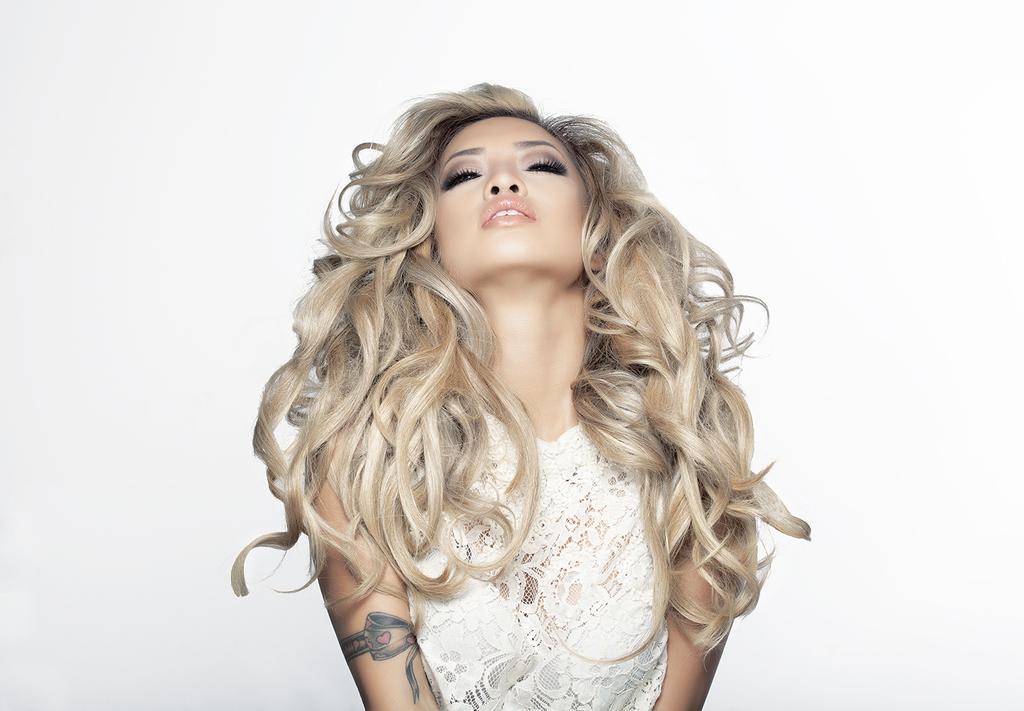In one or two sentences, can you explain what this image depicts? In the picture there is a woman posing for the photo, she has a curly hair and she is wearing white dress and the background of the woman is in white color. 